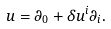<formula> <loc_0><loc_0><loc_500><loc_500>u = \partial _ { 0 } + \delta u ^ { i } \partial _ { i } .</formula> 